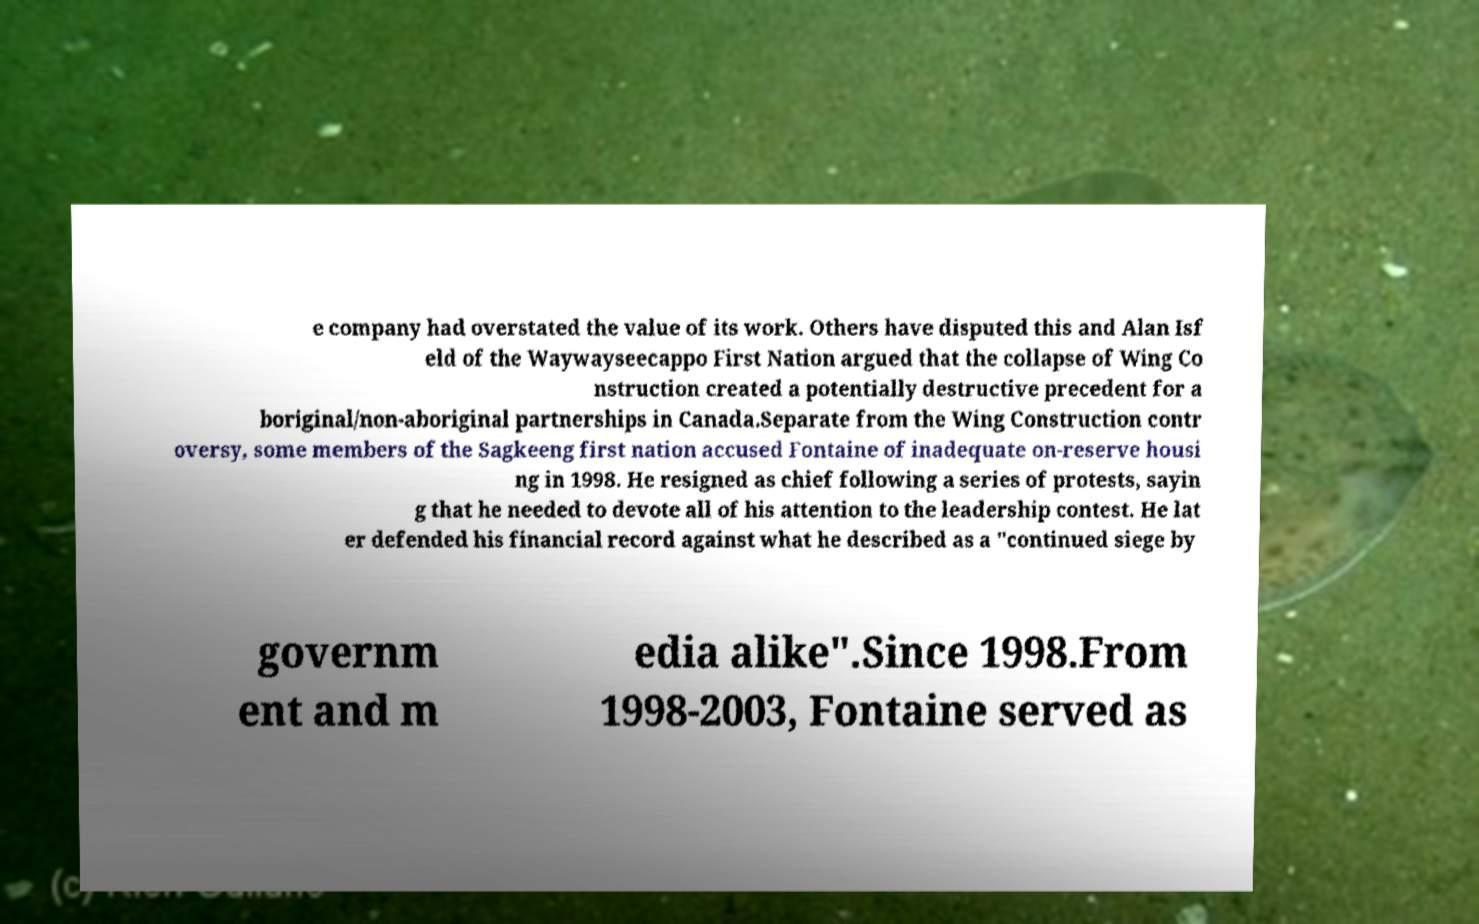Can you accurately transcribe the text from the provided image for me? e company had overstated the value of its work. Others have disputed this and Alan Isf eld of the Waywayseecappo First Nation argued that the collapse of Wing Co nstruction created a potentially destructive precedent for a boriginal/non-aboriginal partnerships in Canada.Separate from the Wing Construction contr oversy, some members of the Sagkeeng first nation accused Fontaine of inadequate on-reserve housi ng in 1998. He resigned as chief following a series of protests, sayin g that he needed to devote all of his attention to the leadership contest. He lat er defended his financial record against what he described as a "continued siege by governm ent and m edia alike".Since 1998.From 1998-2003, Fontaine served as 